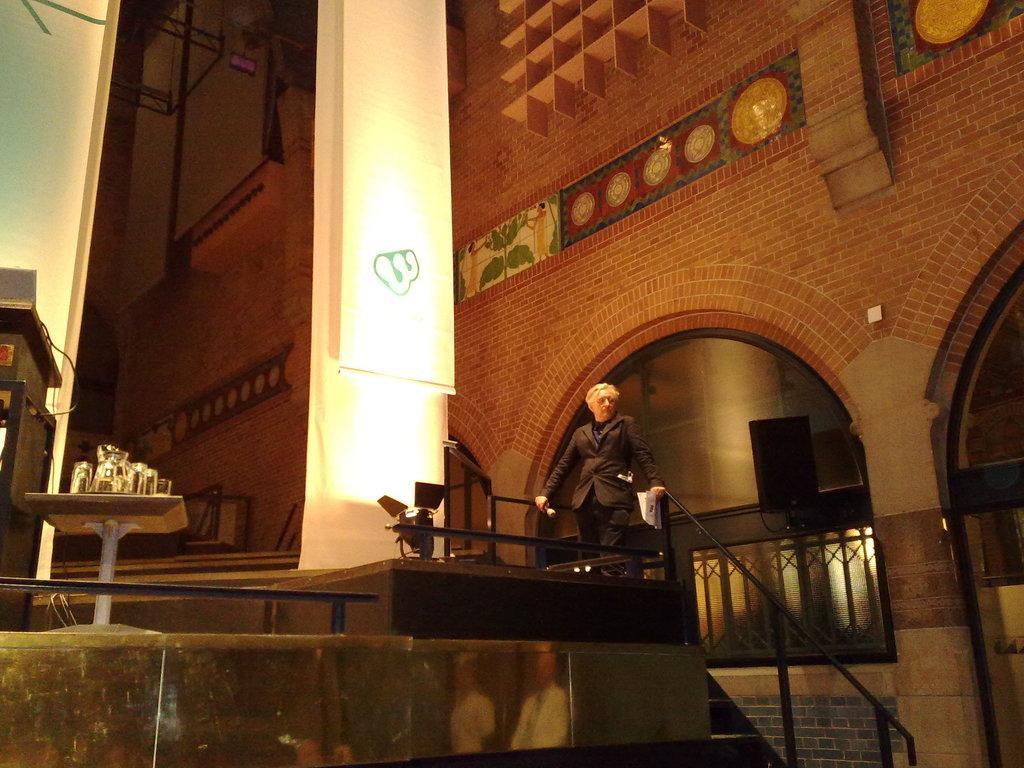How would you summarize this image in a sentence or two? This is a person standing. He is holding a mike and papers in his hands. This looks like a banner hanging. I can see a table with the glass objects on it. This is a building wall. I can see an arch. I think this is a staircase holder. This looks like a speaker. These are the show lights. I can see the painting on the wall. On the left corner of the image, that looks like an object. 